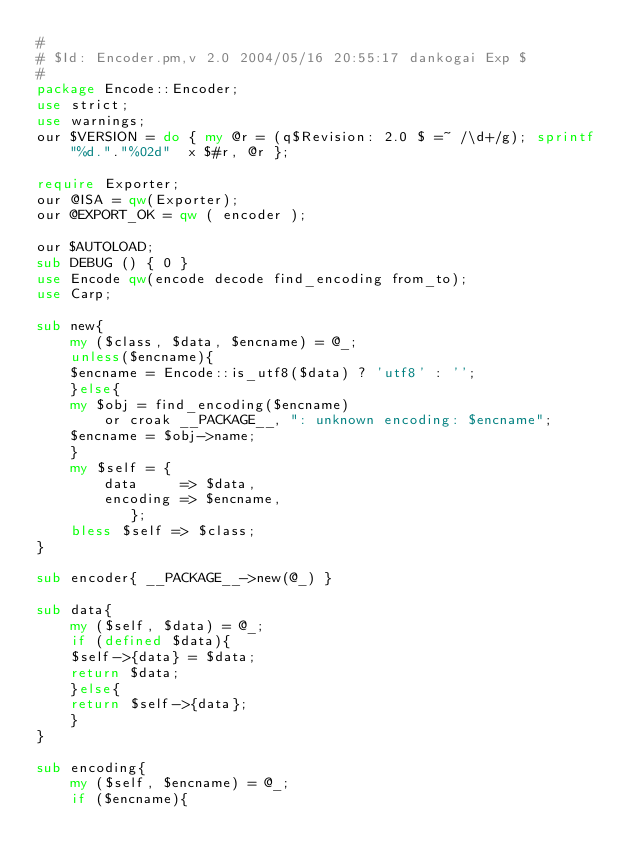Convert code to text. <code><loc_0><loc_0><loc_500><loc_500><_Perl_>#
# $Id: Encoder.pm,v 2.0 2004/05/16 20:55:17 dankogai Exp $
#
package Encode::Encoder;
use strict;
use warnings;
our $VERSION = do { my @r = (q$Revision: 2.0 $ =~ /\d+/g); sprintf "%d."."%02d"  x $#r, @r };

require Exporter;
our @ISA = qw(Exporter);
our @EXPORT_OK = qw ( encoder );

our $AUTOLOAD;
sub DEBUG () { 0 }
use Encode qw(encode decode find_encoding from_to);
use Carp;

sub new{
    my ($class, $data, $encname) = @_;
    unless($encname){
	$encname = Encode::is_utf8($data) ? 'utf8' : '';
    }else{
	my $obj = find_encoding($encname) 
	    or croak __PACKAGE__, ": unknown encoding: $encname";
	$encname = $obj->name;
    }
    my $self = {
		data     => $data,
		encoding => $encname,
	       };
    bless $self => $class;
}

sub encoder{ __PACKAGE__->new(@_) }

sub data{
    my ($self, $data) = @_;
    if (defined $data){
	$self->{data} = $data;
	return $data;
    }else{
	return $self->{data};
    }
}

sub encoding{
    my ($self, $encname) = @_;
    if ($encname){</code> 